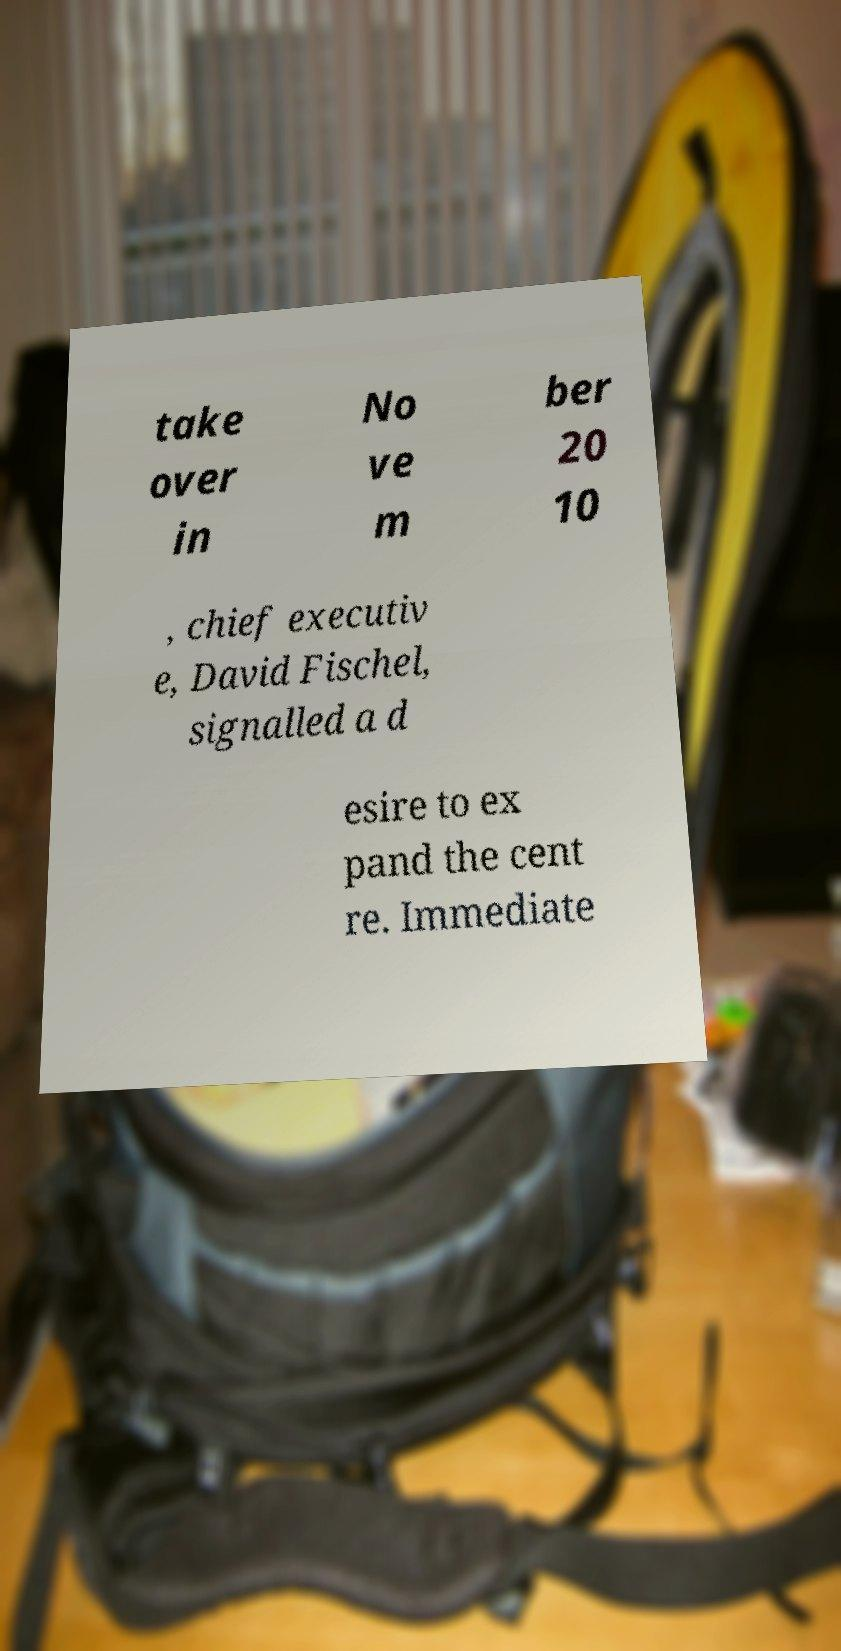There's text embedded in this image that I need extracted. Can you transcribe it verbatim? take over in No ve m ber 20 10 , chief executiv e, David Fischel, signalled a d esire to ex pand the cent re. Immediate 